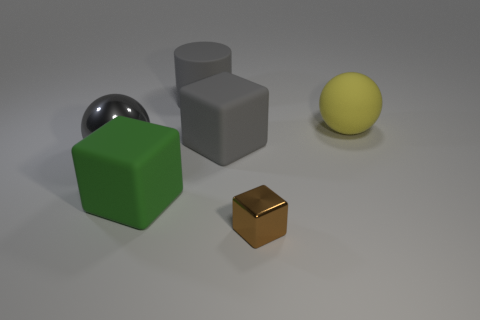Is the rubber ball the same color as the large rubber cylinder?
Your response must be concise. No. There is a object on the left side of the big block in front of the gray metal sphere; how many large gray cylinders are in front of it?
Provide a succinct answer. 0. There is a gray object that is the same material as the gray cylinder; what shape is it?
Offer a terse response. Cube. What material is the big sphere left of the metallic object that is right of the gray matte thing in front of the gray cylinder?
Keep it short and to the point. Metal. How many things are gray things right of the large metal ball or blue metal spheres?
Your answer should be compact. 2. What number of other objects are there of the same shape as the large metal thing?
Ensure brevity in your answer.  1. Are there more gray objects to the left of the green matte thing than tiny shiny things?
Offer a very short reply. No. What size is the green object that is the same shape as the tiny brown metallic thing?
Your answer should be very brief. Large. Is there any other thing that has the same material as the large gray block?
Your answer should be very brief. Yes. What shape is the big yellow rubber thing?
Keep it short and to the point. Sphere. 